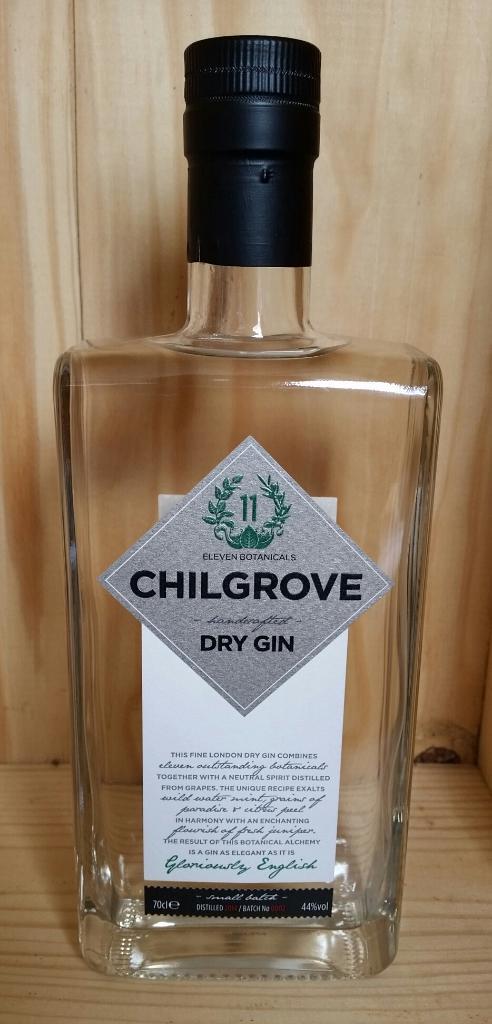What is written on the silver label on the bottle?
Your response must be concise. Chilgrove. 